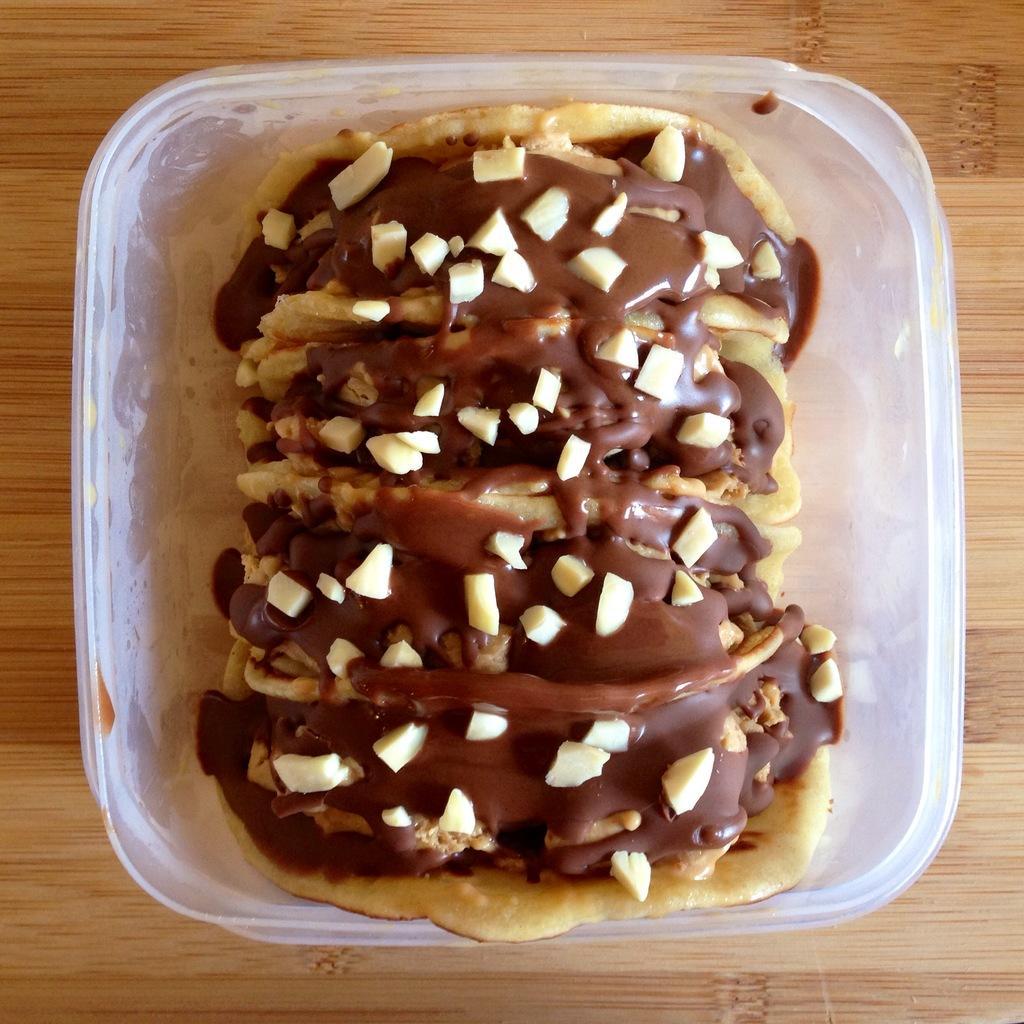Describe this image in one or two sentences. In this picture we can see a bowl with a food item in it and this bowl is placed on a table. 